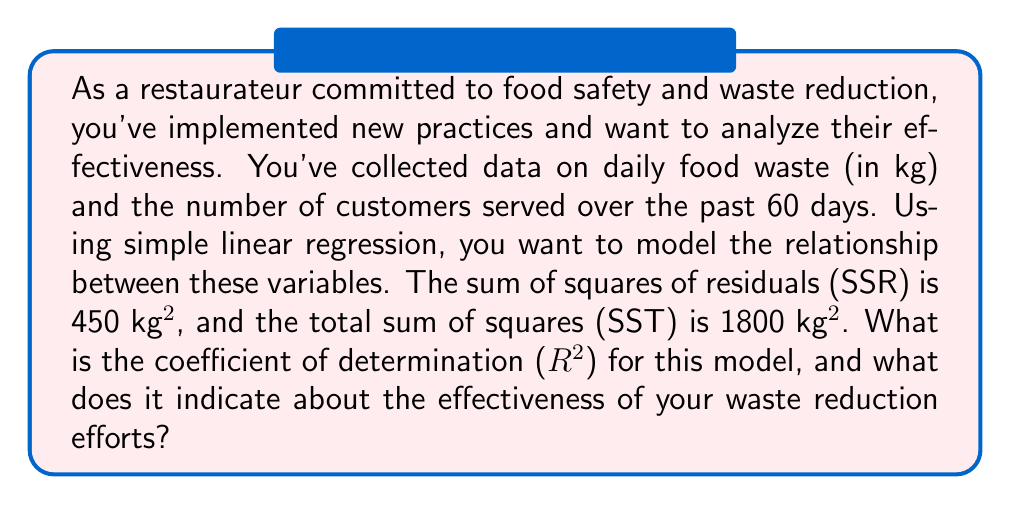Provide a solution to this math problem. To solve this problem, we'll follow these steps:

1. Understand the components:
   - SSR (Sum of Squares of Residuals): Measures the unexplained variation
   - SST (Total Sum of Squares): Measures the total variation in the dependent variable
   - R^2 (Coefficient of Determination): Measures the proportion of variance explained by the model

2. Recall the formula for R^2:

   $$R^2 = 1 - \frac{SSR}{SST}$$

3. Plug in the given values:
   SSR = 450 kg^2
   SST = 1800 kg^2

4. Calculate R^2:

   $$R^2 = 1 - \frac{450}{1800}$$
   $$R^2 = 1 - 0.25$$
   $$R^2 = 0.75$$

5. Interpret the result:
   - R^2 ranges from 0 to 1
   - An R^2 of 0.75 means that 75% of the variance in food waste can be explained by the number of customers served
   - This indicates a strong relationship between the number of customers and food waste

For a restaurateur focused on food safety and waste reduction, this R^2 value suggests that the new practices are effective in managing food waste relative to customer volume. However, there's still room for improvement, as 25% of the variance is unexplained by this model.
Answer: The coefficient of determination (R^2) is 0.75, indicating that 75% of the variance in daily food waste can be explained by the number of customers served. This suggests that the restaurateur's waste reduction efforts are relatively effective, but there may be other factors contributing to food waste that are not accounted for in this model. 